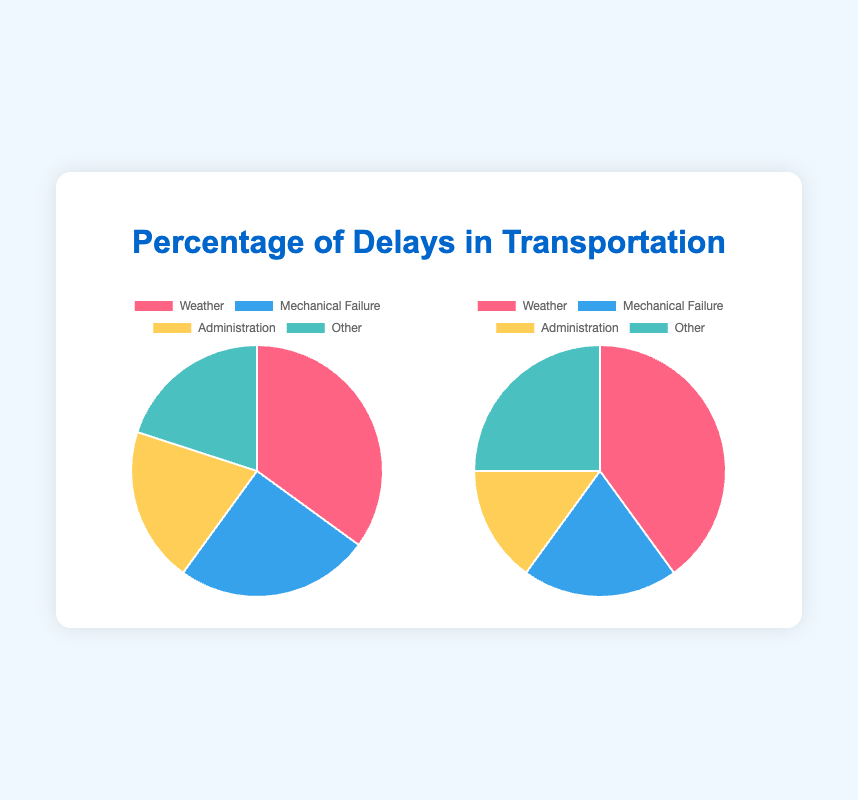What issue causes the highest percentage of delays for airlines? The pie chart shows different issues causing delays in airlines, with Weather having the largest section at 35%.
Answer: Weather What is the combined percentage of delays caused by Administration and Other for shipping lines? The Administration and Other sections combined can be calculated by adding 15% (Administration) and 25% (Other), which equals 40%.
Answer: 40% Compare the percentage of delays caused by Mechanical Failure between airlines and shipping lines. The pie charts show that Mechanical Failure causes 25% of delays in airlines and 20% in shipping lines. Hence, airlines have a higher percentage.
Answer: Airlines Which issue has the smallest section in the pie chart for shipping lines? By inspecting the pie chart for shipping lines, Administration has the smallest section at 15%.
Answer: Administration What is the average percentage of delays caused by all issues in airlines? Sum the individual percentages for Weather (35%), Mechanical Failure (25%), Administration (20%), and Other (20%) which equals 100%. The average is 100% divided by 4 issues, so it's 25%.
Answer: 25% Compare the total percentages caused by Weather and Other between airlines and shipping lines. Which is higher? For airlines, Weather is 35% and Other is 20%, totaling 55%. For shipping lines, Weather is 40% and Other is 25%, totaling 65%. Shipping lines have the higher total.
Answer: Shipping lines What percentage more do weather-related delays in shipping lines account for compared to Administration-related delays? Weather-related delays are 40% and Administration-related delays are 15%. The difference is 40% - 15% = 25%.
Answer: 25% How much higher is the percentage of delays caused by Weather in shipping lines compared to airlines? Weather causes delays in shipping lines at 40% and in airlines at 35%. The difference is 40% - 35% = 5%.
Answer: 5% Which category shows no difference in the percentage of delays between airlines and shipping lines? Observation reveals that the percentage for Administration in airlines is 20% and in shipping lines it’s 15%. Other also shows 20% for airlines and 25% for shipping lines. Mechanical Failure shows a difference of 5%. The unique case is Weather, which is higher in shipping lines, making each not identical between both modes.
Answer: None 